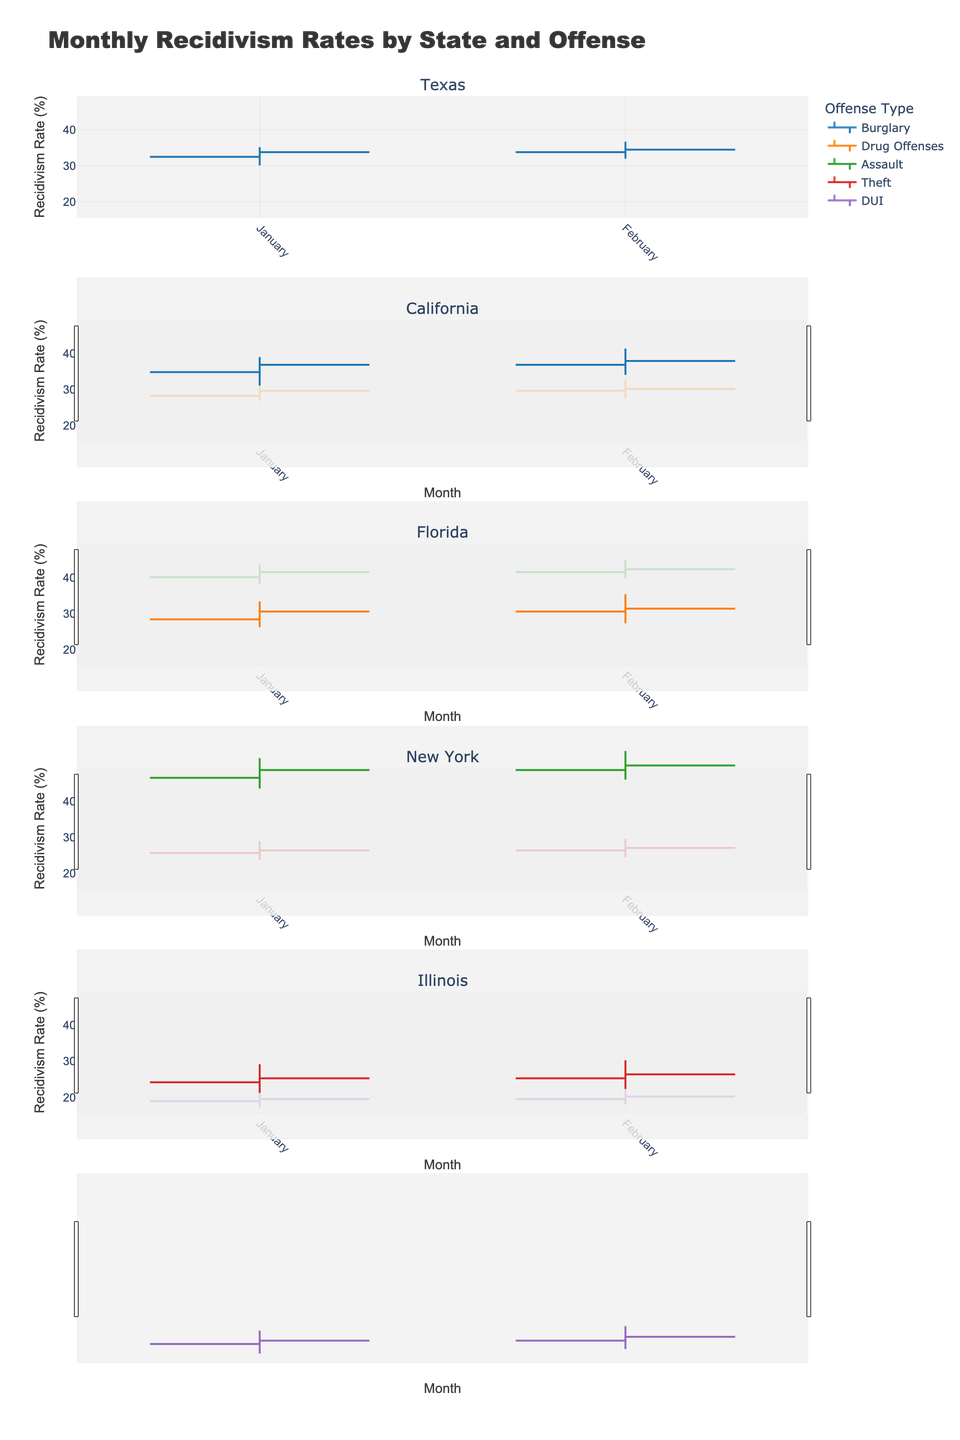What's the title of the figure? The title can be found at the top of the chart and is meant to give a clear summary of what the figure represents. In this case, it describes that the data is about monthly recidivism rates by state and offense.
Answer: Monthly Recidivism Rates by State and Offense How many states are included in the figure? The figure has separate subplots for each state, each titled with the state's name at the top of the subplot. Counting these titles will give the number of states represented.
Answer: 5 Which offense in Texas has the highest high value in January? Look at the subplot for Texas, then identify the High values for each offense in January by hovering over or identifying the visual peak. For Texas in January, Burglary has the highest High value.
Answer: Burglary What's the average Close value for California in the first two months of the year for Drug Offenses? To find the average Close value, sum the Close values for January and February for Drug Offenses in California, then divide by 2: (29.7 + 30.2) / 2 = 29.95
Answer: 29.95 In Florida, how does the January Close value for Assault compare to February? Look at the Close values for January and February for Assault in Florida. Compare these values to see which one is higher. January's Close value is 41.5 and February's is 42.3.
Answer: February is higher For New York's Theft category, what's the difference in the Low values between January and February? Identify the Low values for January and February for Theft in New York, then subtract the January Low value from the February Low value: 24.5 - 23.8 = 0.7
Answer: 0.7 How does Illinois' January Close value for DUI offenses differ from February? Look at the subplot for Illinois and identify the Close values for January and February for DUI offenses. Subtract January's Close value from February's: 20.2 - 19.5 = 0.7
Answer: 0.7 Which state shows the highest range (difference between High and Low values) for any offense and month? Calculate the range (High - Low) for each offense and month across all states, then identify the highest value. Florida's Assault in February has the highest range (44.9 - 39.8 = 5.1).
Answer: Florida in February for Assault Name the month with the highest recidivism rate for Drug Offenses in California. For Drug Offenses in California, compare the High values listed by month and identify the month with the highest value. February has the highest High value of 32.8.
Answer: February 